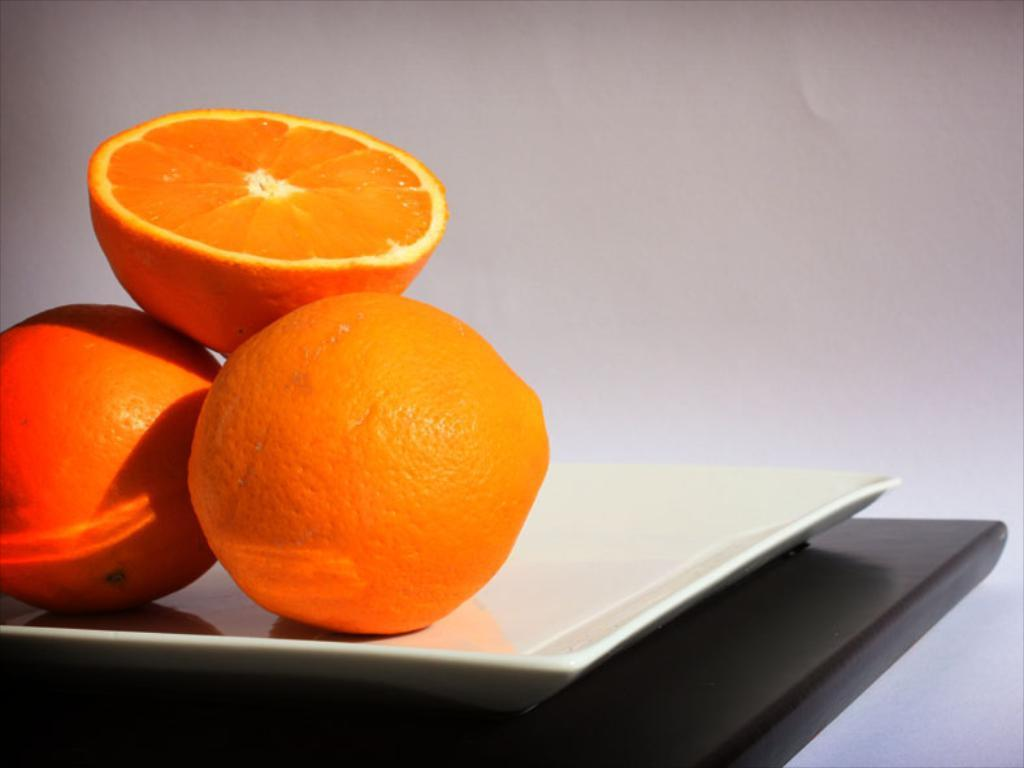What is the main food item featured in the image? There is an orange slice in the image. Where is the orange slice placed? The orange slice is on a plate. Are there any other orange-related items in the image? Yes, there are oranges in the image. What is the plate resting on in the image? The plate is on a platform. What can be seen in the background of the image? There is a wall in the background of the image. Can you see any bees or zebras interacting with the oranges in the image? No, there are no bees or zebras present in the image. 